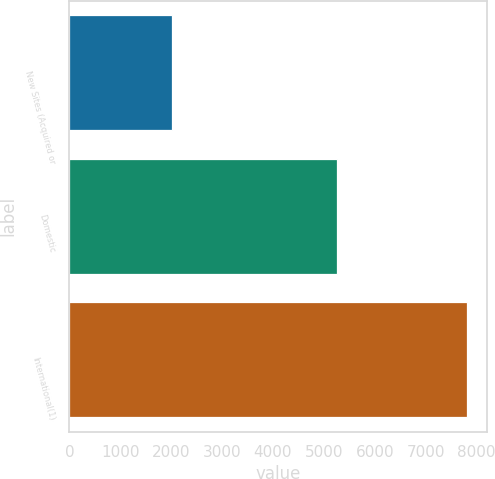<chart> <loc_0><loc_0><loc_500><loc_500><bar_chart><fcel>New Sites (Acquired or<fcel>Domestic<fcel>International(1)<nl><fcel>2013<fcel>5260<fcel>7810<nl></chart> 